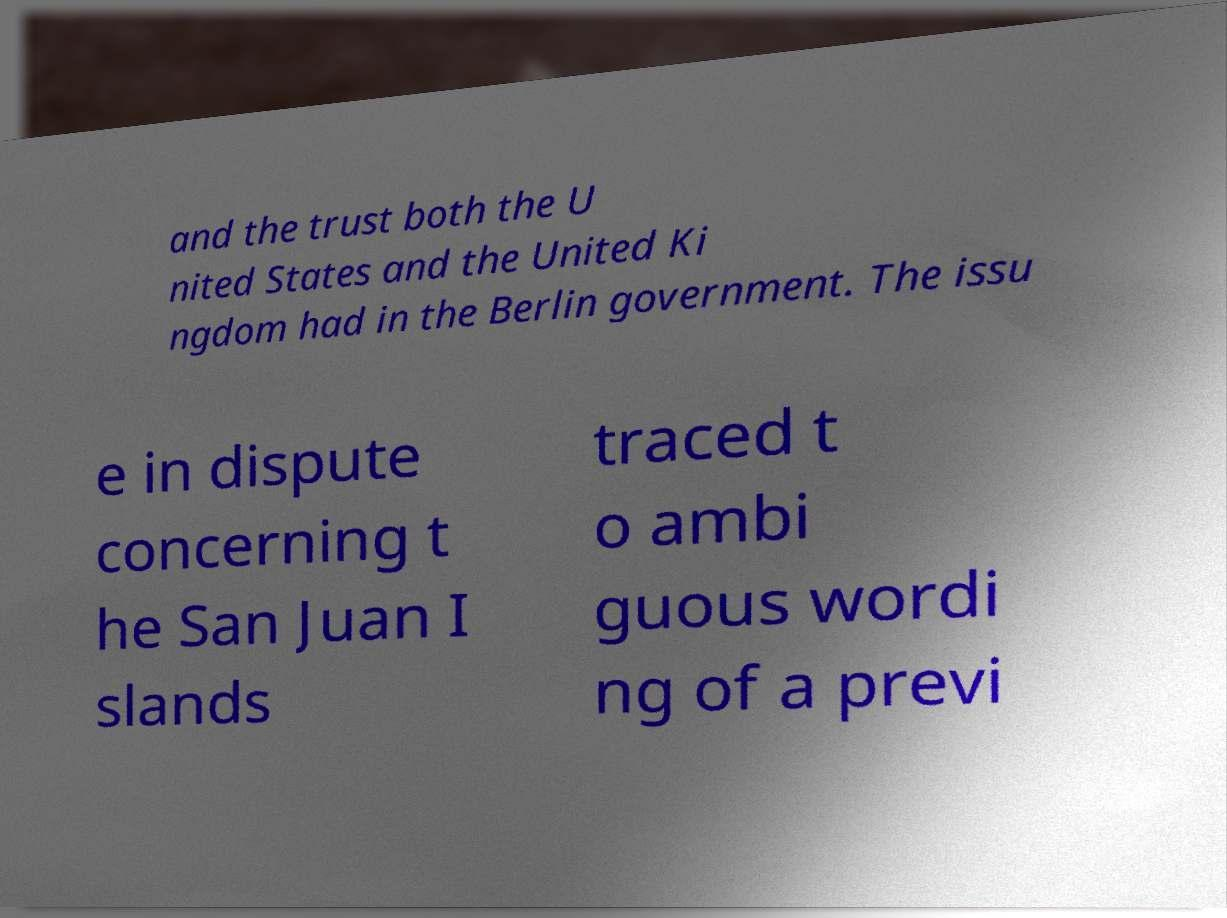Please identify and transcribe the text found in this image. and the trust both the U nited States and the United Ki ngdom had in the Berlin government. The issu e in dispute concerning t he San Juan I slands traced t o ambi guous wordi ng of a previ 